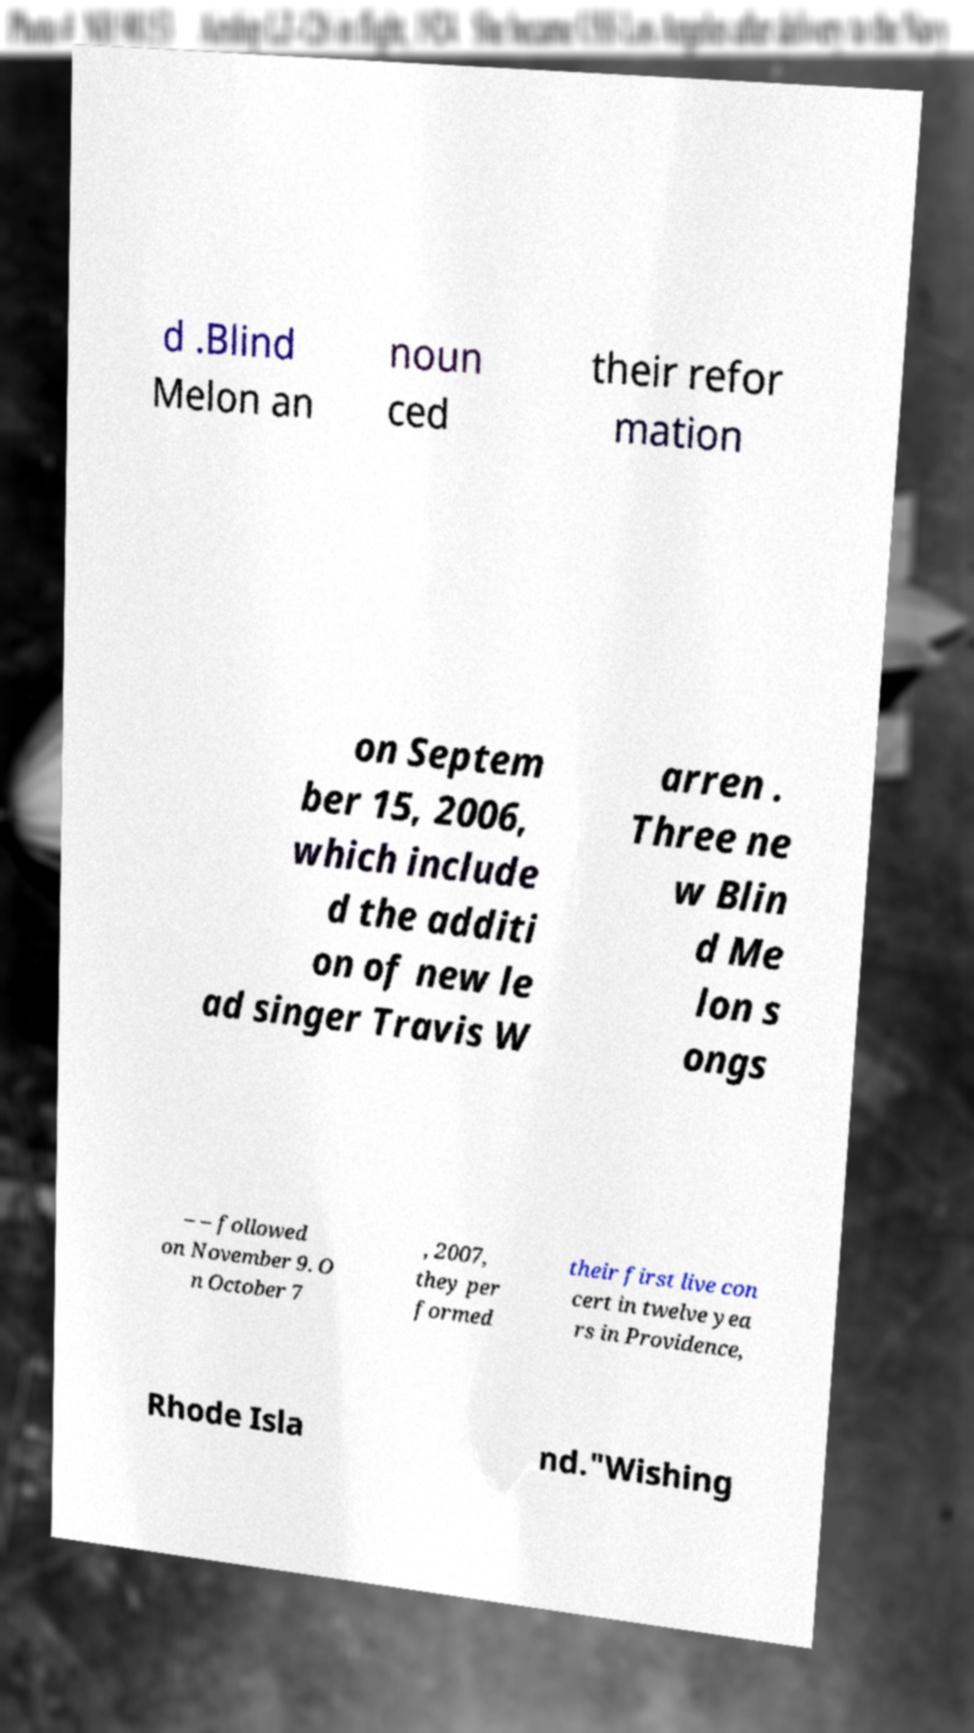For documentation purposes, I need the text within this image transcribed. Could you provide that? d .Blind Melon an noun ced their refor mation on Septem ber 15, 2006, which include d the additi on of new le ad singer Travis W arren . Three ne w Blin d Me lon s ongs – – followed on November 9. O n October 7 , 2007, they per formed their first live con cert in twelve yea rs in Providence, Rhode Isla nd."Wishing 